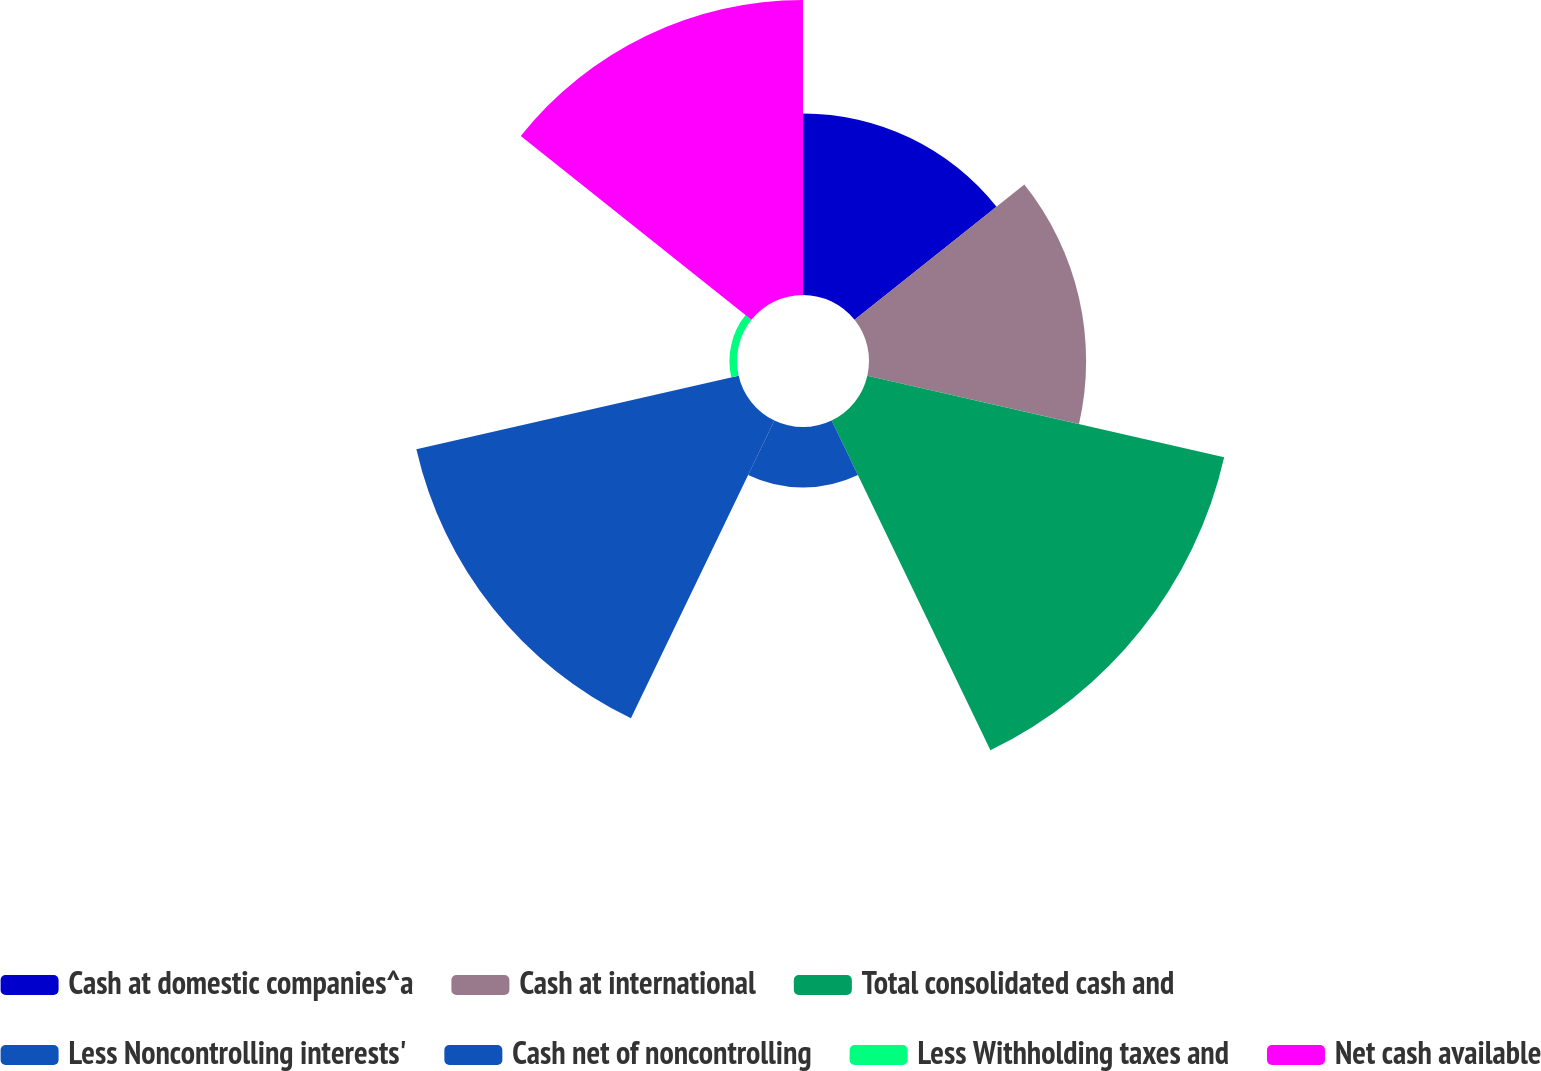<chart> <loc_0><loc_0><loc_500><loc_500><pie_chart><fcel>Cash at domestic companies^a<fcel>Cash at international<fcel>Total consolidated cash and<fcel>Less Noncontrolling interests'<fcel>Cash net of noncontrolling<fcel>Less Withholding taxes and<fcel>Net cash available<nl><fcel>12.45%<fcel>14.89%<fcel>25.1%<fcel>4.15%<fcel>22.67%<fcel>0.52%<fcel>20.23%<nl></chart> 